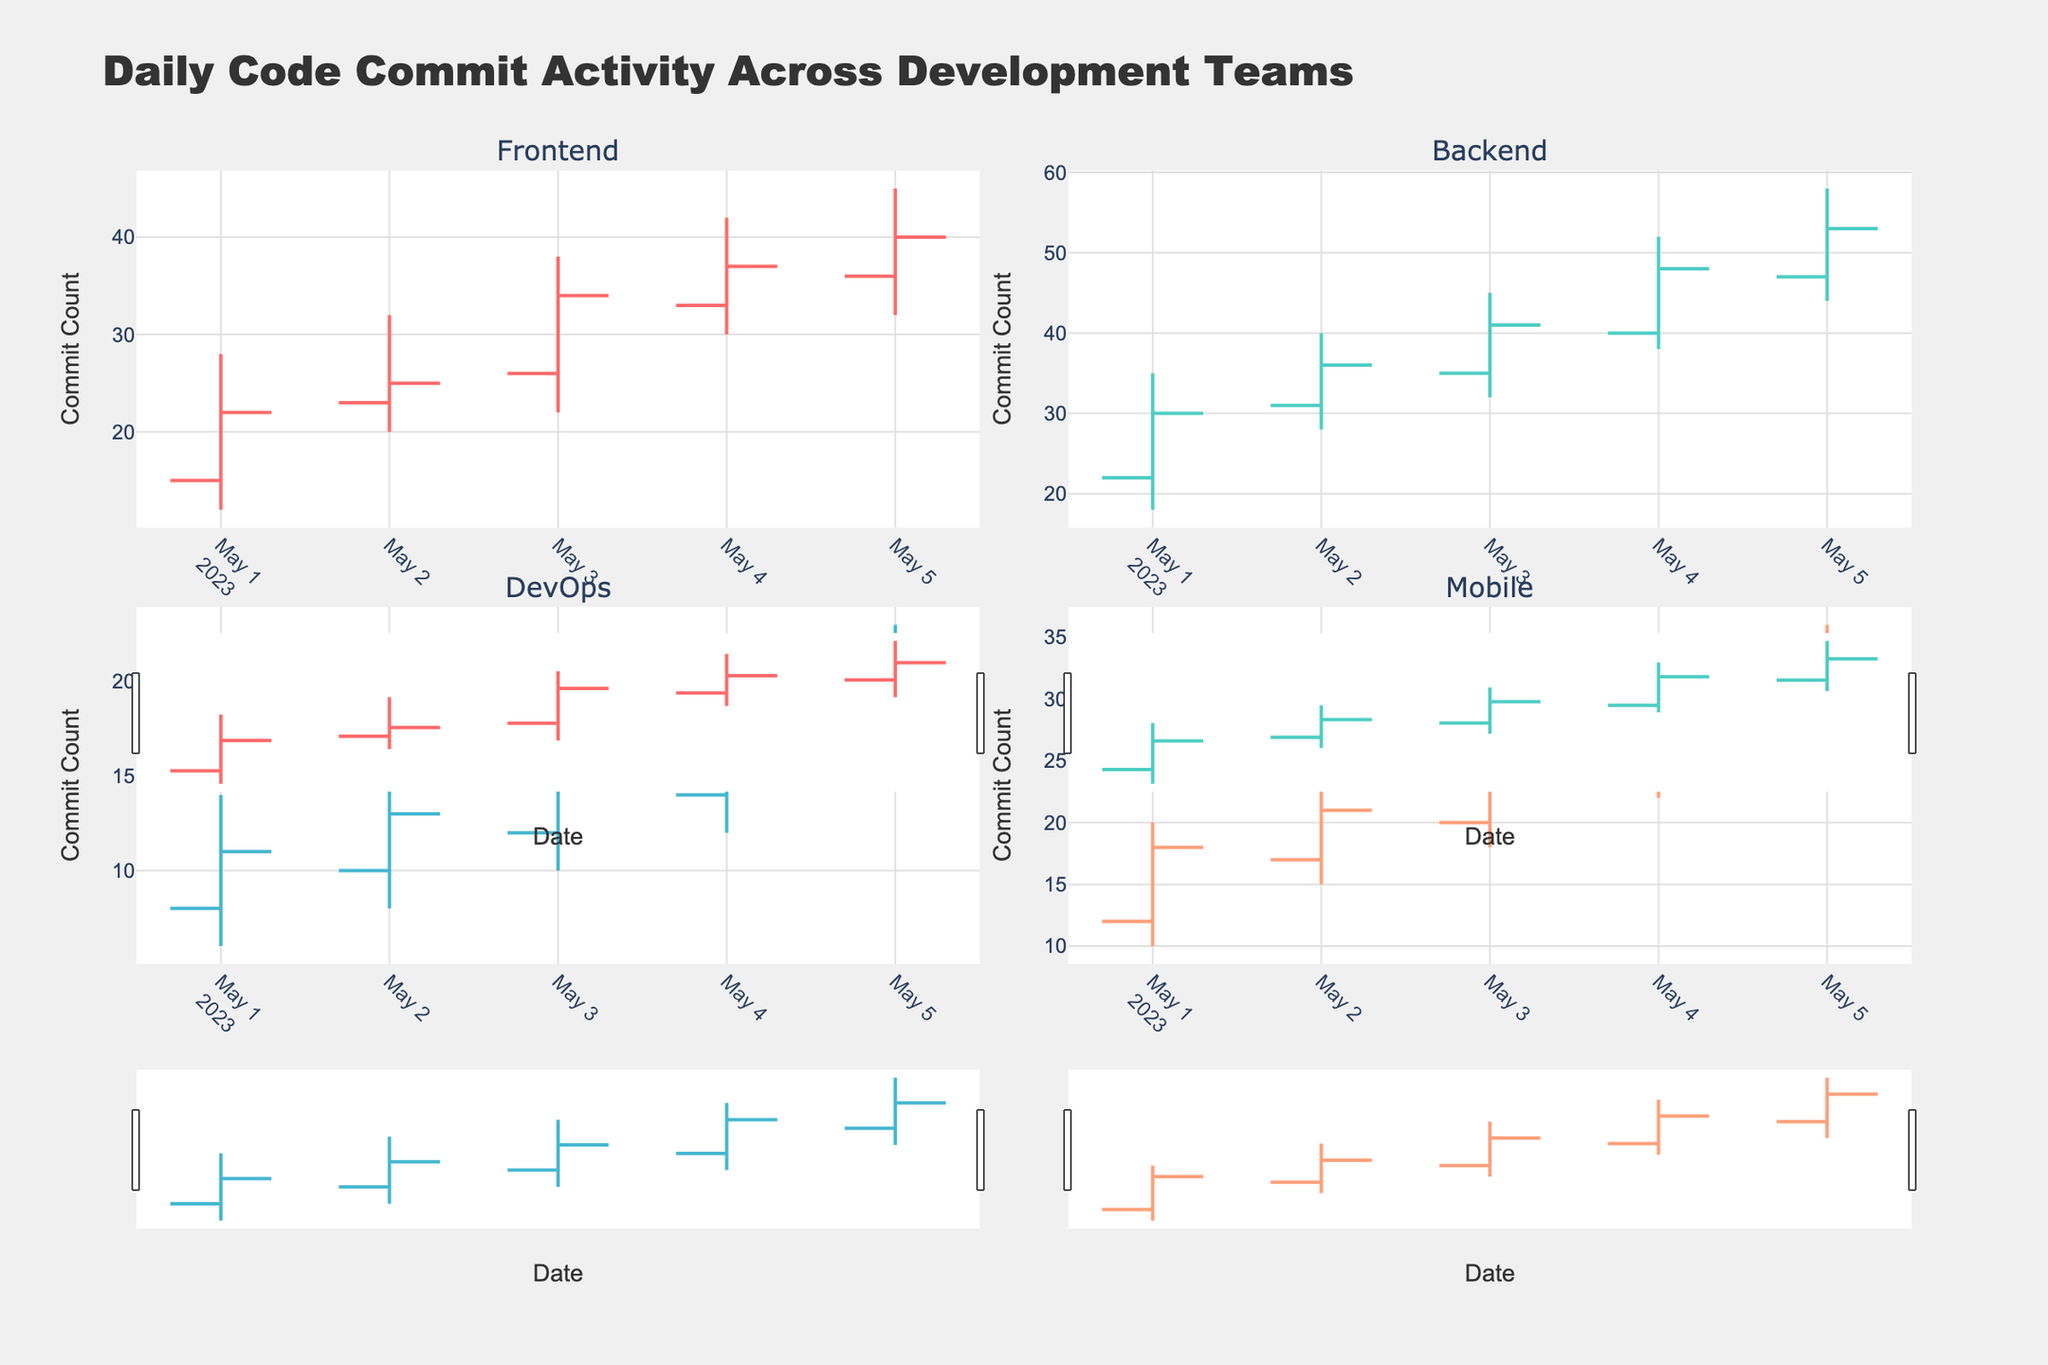What is the title of the figure? The title is displayed at the top center of the figure and reads 'Daily Code Commit Activity Across Development Teams'.
Answer: Daily Code Commit Activity Across Development Teams How many teams are represented in the figure? The figure consists of four subplots, each with a title referring to a team's name.
Answer: Four Which team had the highest high commit count, and what was that value? The highest high commit count is found by comparing the high commit counts across all subplots. Backend team had a high of 58 on May 5, 2023.
Answer: Backend, 58 For the Mobile team, what was their lowest commit count and on which date was it observed? The lowest commit count for the Mobile team is found by looking at the lowest values in its subplot. It was 10 on May 1, 2023.
Answer: 10, May 1, 2023 Which team showed the most consistent commit count range without large fluctuations? Consistency is observed by comparing the range between high and low commit counts. DevOps team showed lower and more consistent ranges compared to others.
Answer: DevOps On May 5, which team had the highest number of commits at the end of the day? The close value on May 5 for each team is compared. Backend team had the highest close value of 53.
Answer: Backend What is the total increase in the close commit count for the Frontend team from May 1 to May 5? The total increase is calculated by subtracting the close value on May 1 from the close value on May 5. Increase = 40 - 22 = 18.
Answer: 18 Comparing the Backend and Frontend teams, which one had more days where the opening commit count was higher than 30? For each team, count the number of days where the 'Open' column exceeds 30. Backend had 3 days, Frontend had 2 days.
Answer: Backend Which date recorded the highest high commit count across all teams and what was that value? By comparing all 'High' values in the subplots, May 5 recorded the highest with the Backend team's value of 58.
Answer: May 5, 58 Which team had the highest volatility in commit counts on May 4, and how can you tell? Volatility can be observed by the length of the candlestick (difference between high and low). Backend had the highest volatility with a range of 52 - 38 = 14.
Answer: Backend 